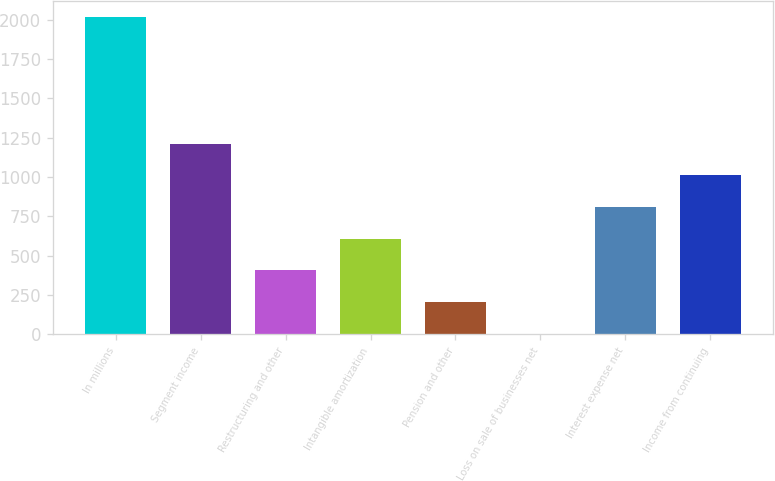<chart> <loc_0><loc_0><loc_500><loc_500><bar_chart><fcel>In millions<fcel>Segment income<fcel>Restructuring and other<fcel>Intangible amortization<fcel>Pension and other<fcel>Loss on sale of businesses net<fcel>Interest expense net<fcel>Income from continuing<nl><fcel>2016<fcel>1211.16<fcel>406.32<fcel>607.53<fcel>205.11<fcel>3.9<fcel>808.74<fcel>1009.95<nl></chart> 